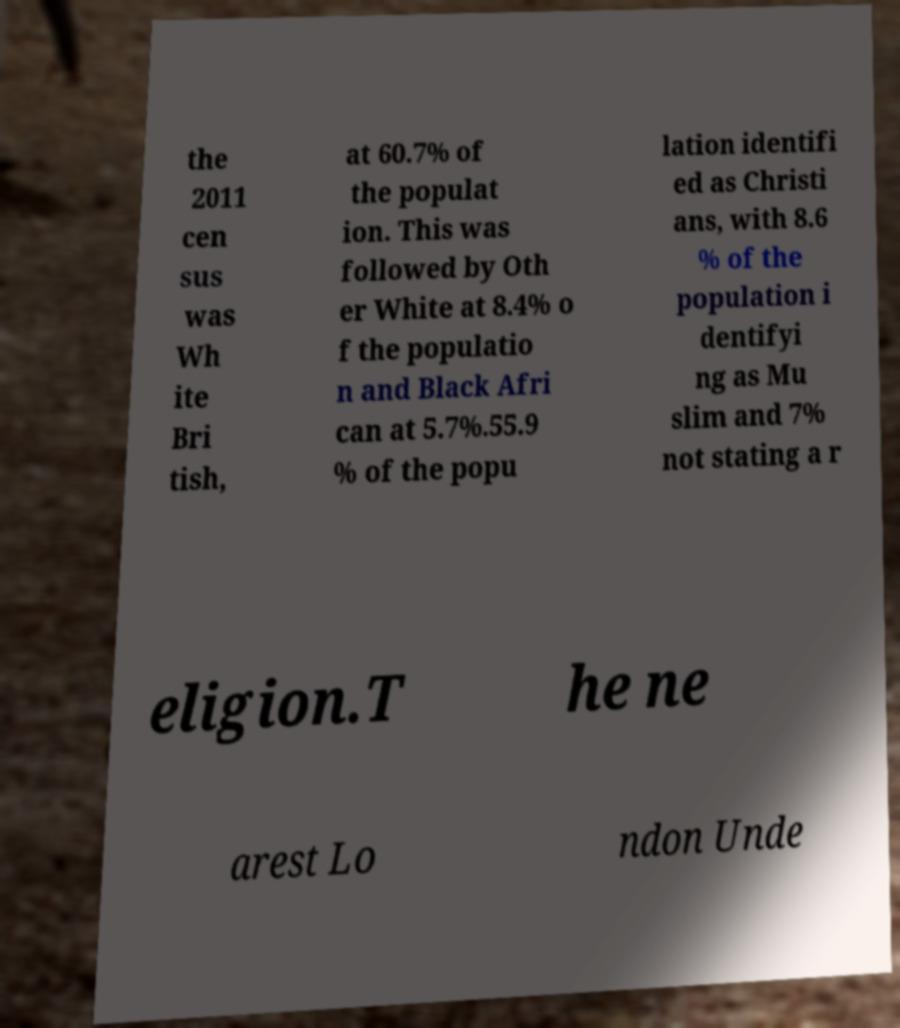There's text embedded in this image that I need extracted. Can you transcribe it verbatim? the 2011 cen sus was Wh ite Bri tish, at 60.7% of the populat ion. This was followed by Oth er White at 8.4% o f the populatio n and Black Afri can at 5.7%.55.9 % of the popu lation identifi ed as Christi ans, with 8.6 % of the population i dentifyi ng as Mu slim and 7% not stating a r eligion.T he ne arest Lo ndon Unde 